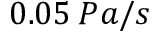Convert formula to latex. <formula><loc_0><loc_0><loc_500><loc_500>0 . 0 5 \, P a / s</formula> 